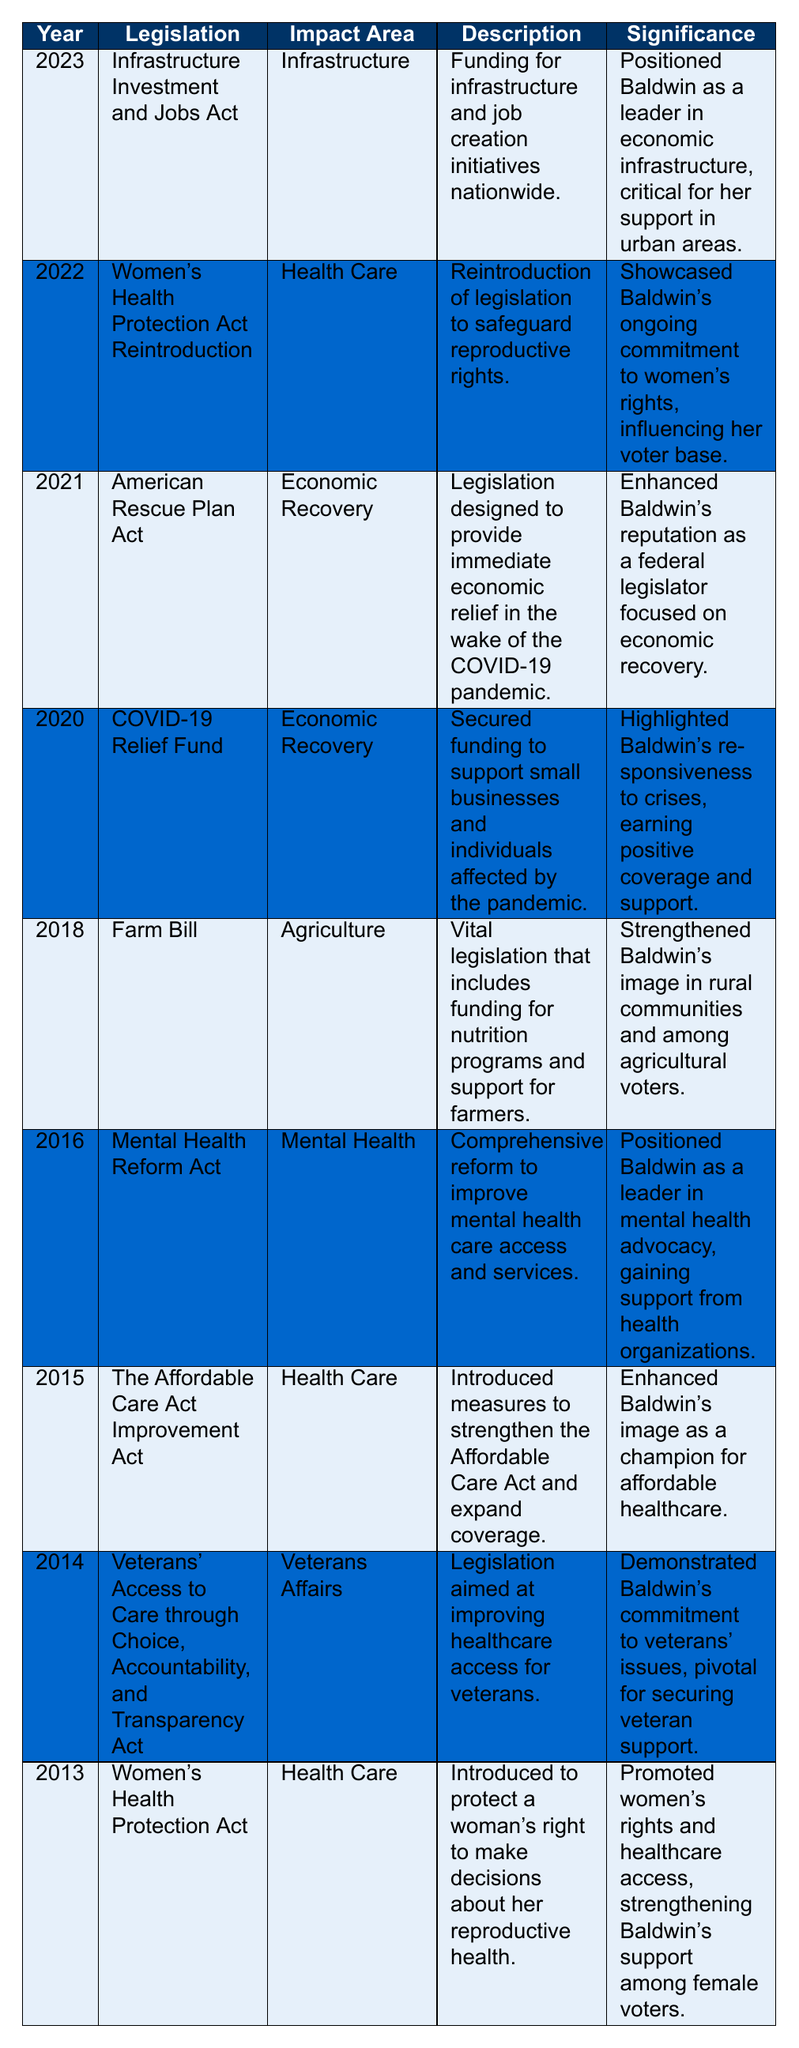What legislation did Tammy Baldwin introduce in 2013? According to the table, the legislation introduced by Tammy Baldwin in 2013 was the Women's Health Protection Act.
Answer: Women's Health Protection Act What was the impact area of the American Rescue Plan Act? The table indicates that the impact area for the American Rescue Plan Act, introduced in 2021, was Economic Recovery.
Answer: Economic Recovery How many health care-related legislative accomplishments did Baldwin achieve from 2013 to 2023? By reviewing the table, the health care-related accomplishments include: Women's Health Protection Act (2013), The Affordable Care Act Improvement Act (2015), Mental Health Reform Act (2016), and Women's Health Protection Act Reintroduction (2022), totaling 4 accomplishments.
Answer: 4 What is the significance of the Farm Bill according to the table? The table states that the significance of the Farm Bill, enacted in 2018, was to strengthen Baldwin's image in rural communities and among agricultural voters.
Answer: Strengthened Baldwin's image in rural communities and among agricultural voters Did Tammy Baldwin focus on economic recovery more than on health care between 2020 and 2021? In the table, during 2020, she worked on the COVID-19 Relief Fund and in 2021, the American Rescue Plan Act, both focusing on Economic Recovery. In health care, she had efforts like the Women's Health Protection Act. Therefore, her focus on economic recovery during these years is evident but cannot be directly quantified without specific accomplishments for each area within that timeframe.
Answer: Yes, she focused on economic recovery during those years What was the primary focus of the legislation introduced in 2016? The legislation introduced in 2016 was the Mental Health Reform Act, which primarily aimed to improve mental health care access and services.
Answer: Improve mental health care access and services In which year was the Veterans' Access to Care through Choice, Accountability, and Transparency Act introduced? The table shows that this legislation was introduced in 2014.
Answer: 2014 Which legislation is associated with funding for infrastructure and job creation? The Infrastructure Investment and Jobs Act is associated with funding for infrastructure and job creation initiatives, according to the table.
Answer: Infrastructure Investment and Jobs Act How many years did Tammy Baldwin make legislative advancements in Economic Recovery from 2020 to 2023? The table shows that there were legislative advancements in Economic Recovery in both 2020 (COVID-19 Relief Fund) and 2021 (American Rescue Plan Act), totaling 2 years of advancements in this area.
Answer: 2 years 